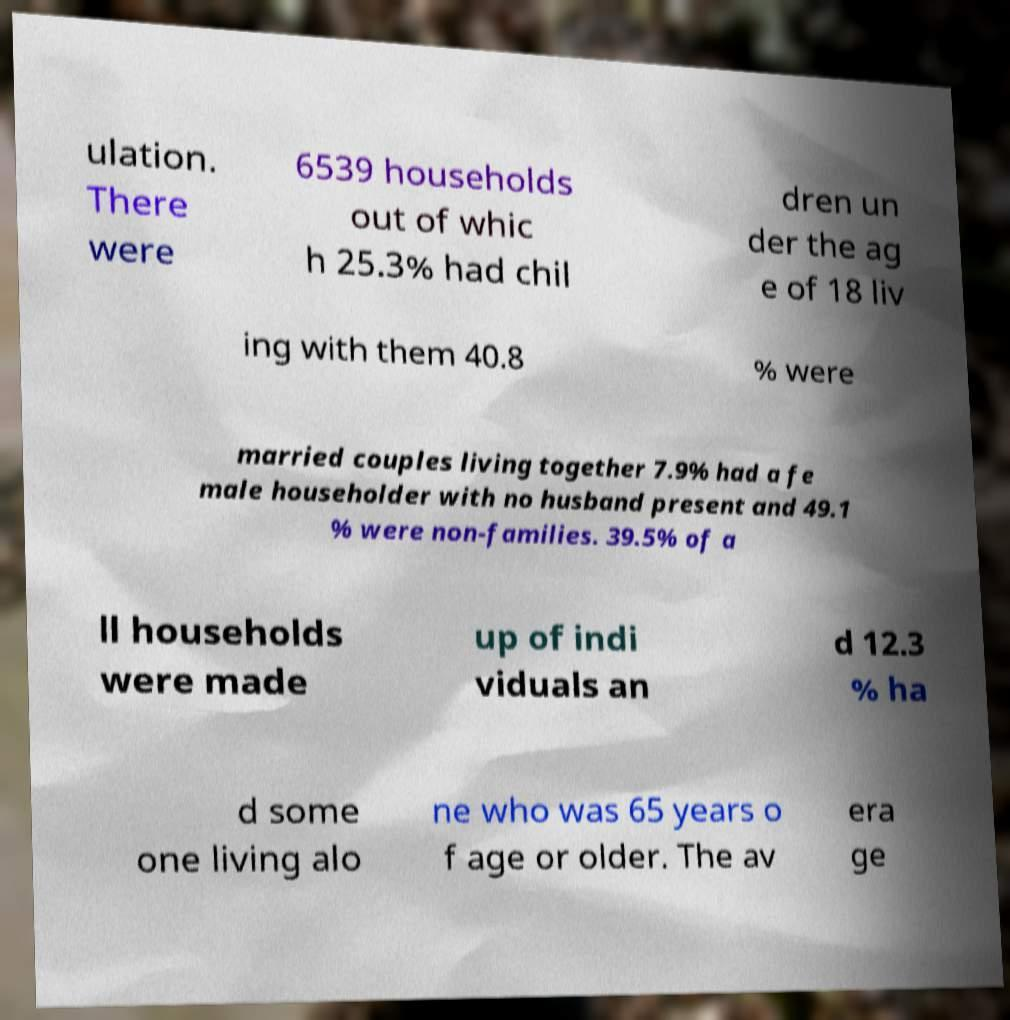Could you extract and type out the text from this image? ulation. There were 6539 households out of whic h 25.3% had chil dren un der the ag e of 18 liv ing with them 40.8 % were married couples living together 7.9% had a fe male householder with no husband present and 49.1 % were non-families. 39.5% of a ll households were made up of indi viduals an d 12.3 % ha d some one living alo ne who was 65 years o f age or older. The av era ge 